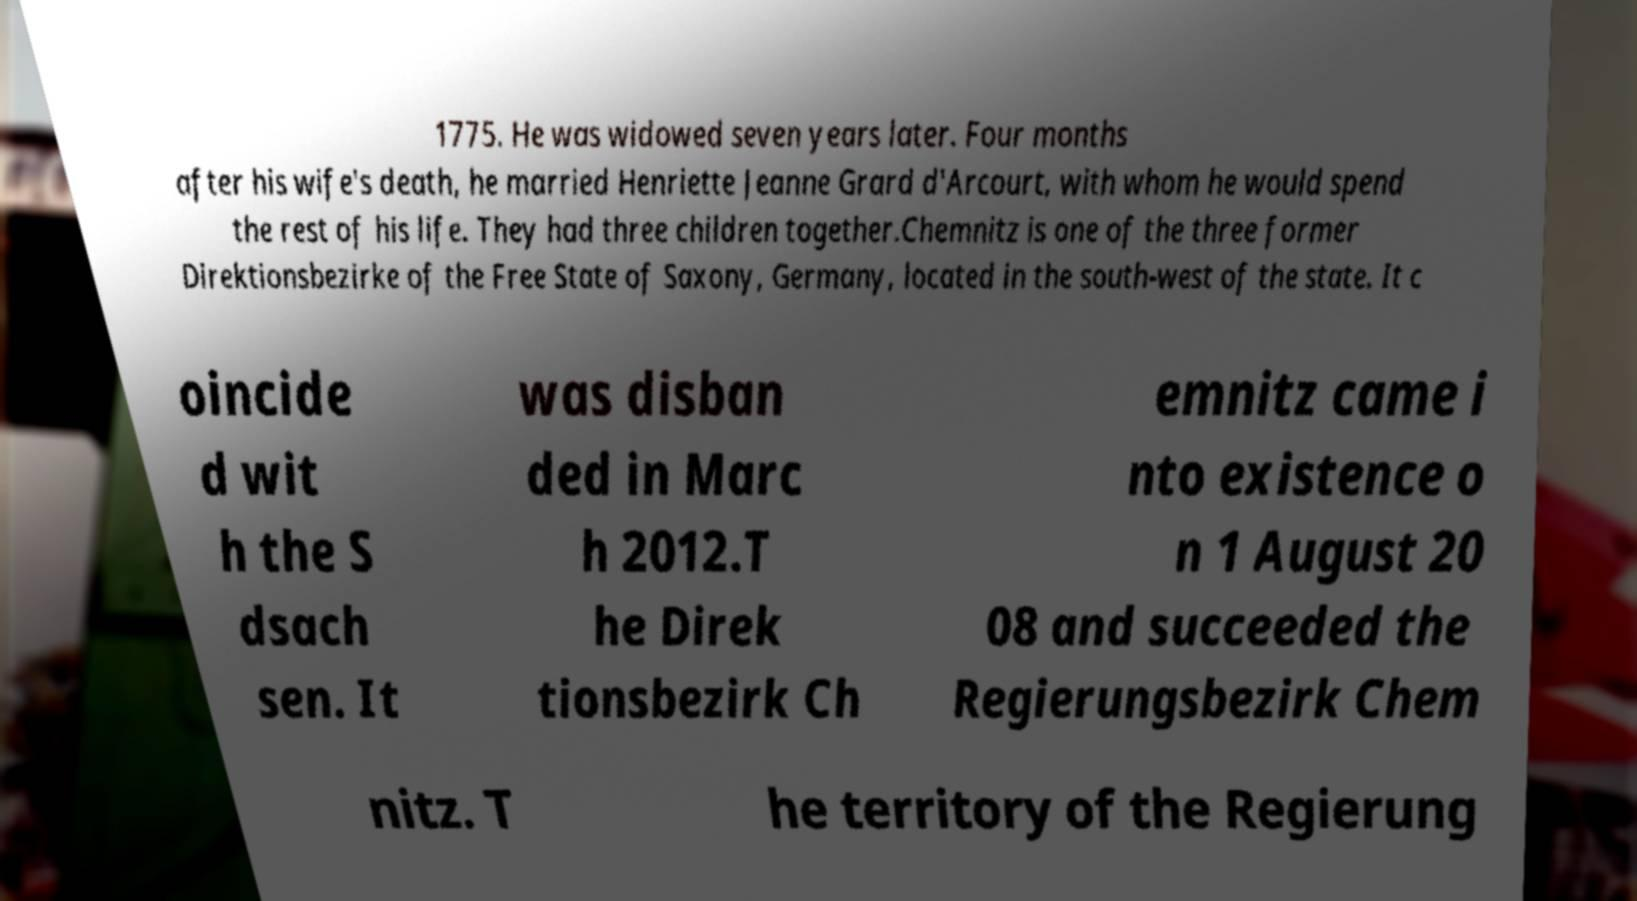There's text embedded in this image that I need extracted. Can you transcribe it verbatim? 1775. He was widowed seven years later. Four months after his wife's death, he married Henriette Jeanne Grard d'Arcourt, with whom he would spend the rest of his life. They had three children together.Chemnitz is one of the three former Direktionsbezirke of the Free State of Saxony, Germany, located in the south-west of the state. It c oincide d wit h the S dsach sen. It was disban ded in Marc h 2012.T he Direk tionsbezirk Ch emnitz came i nto existence o n 1 August 20 08 and succeeded the Regierungsbezirk Chem nitz. T he territory of the Regierung 